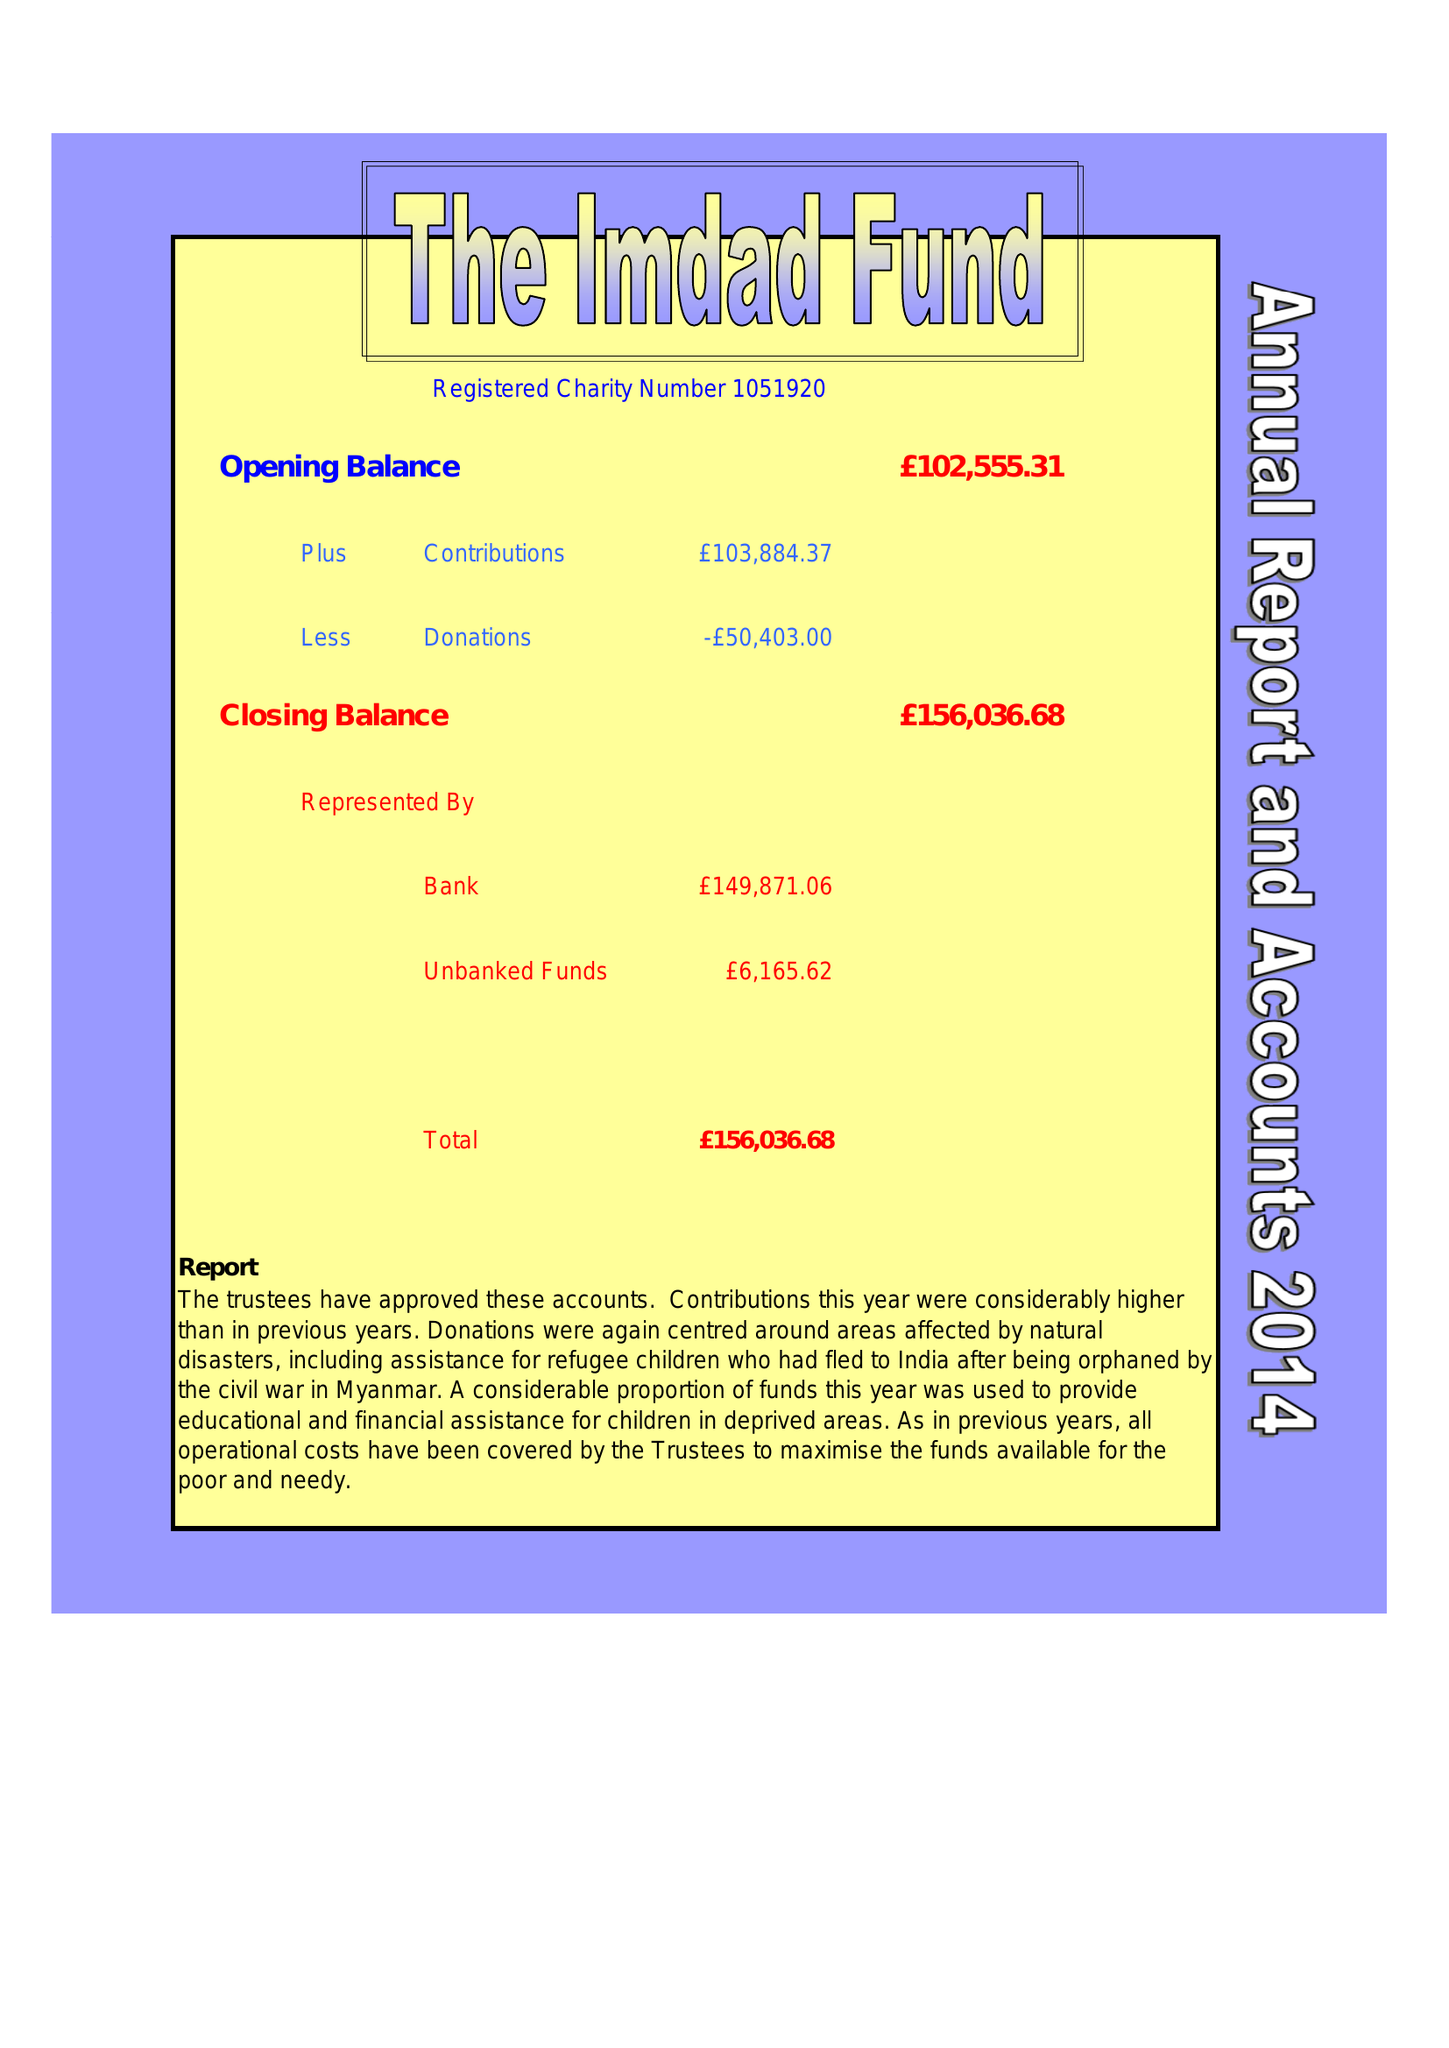What is the value for the report_date?
Answer the question using a single word or phrase. 2014-12-31 